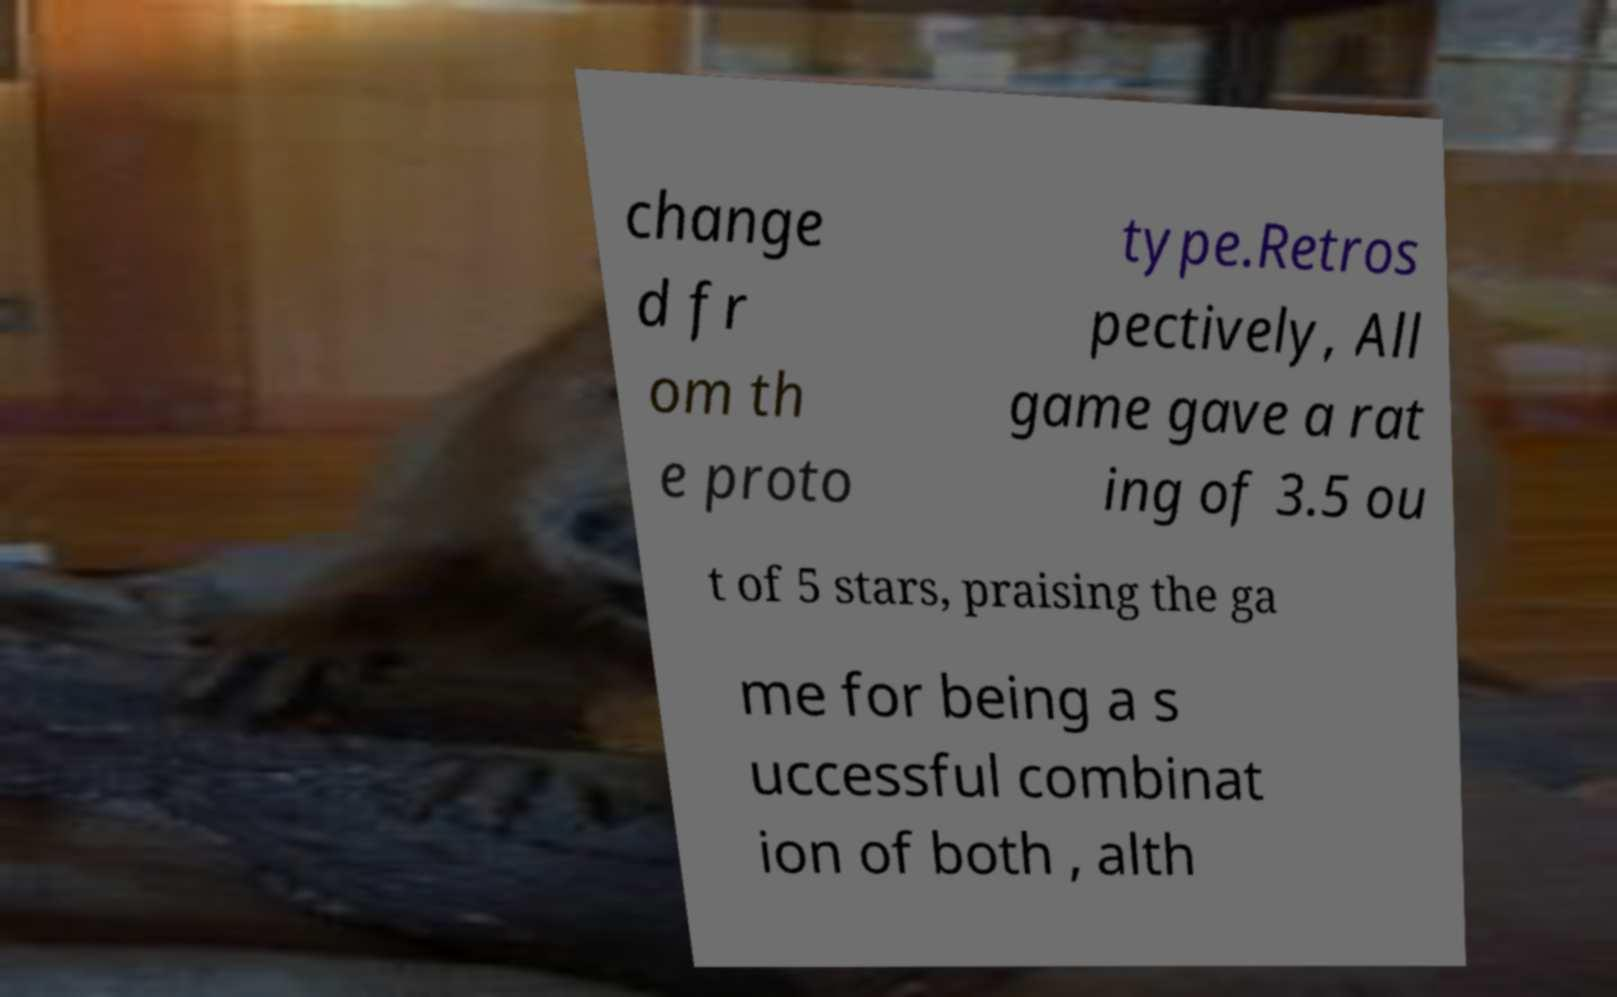Could you extract and type out the text from this image? change d fr om th e proto type.Retros pectively, All game gave a rat ing of 3.5 ou t of 5 stars, praising the ga me for being a s uccessful combinat ion of both , alth 